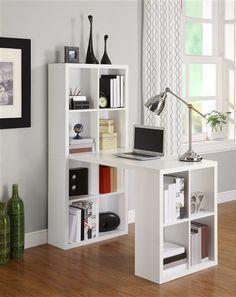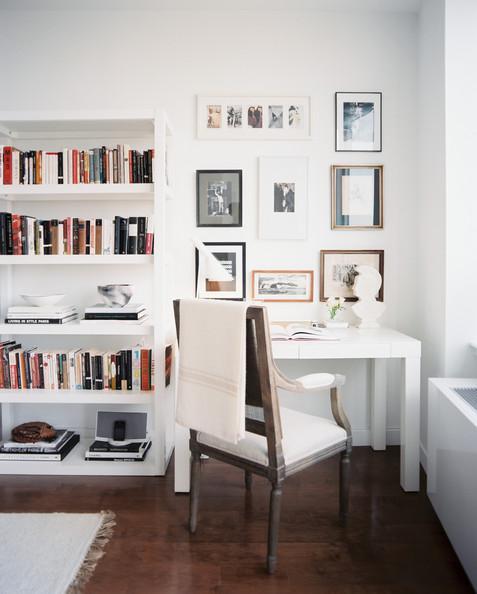The first image is the image on the left, the second image is the image on the right. Assess this claim about the two images: "In one image a white desk and shelf unit has one narrow end against a wall, while the other image is a white shelf unit flush to the wall with a chair in front of it.". Correct or not? Answer yes or no. Yes. The first image is the image on the left, the second image is the image on the right. For the images displayed, is the sentence "An image shows a white storage piece with its taller end flush against a wall and a computer atop the desk part." factually correct? Answer yes or no. Yes. 